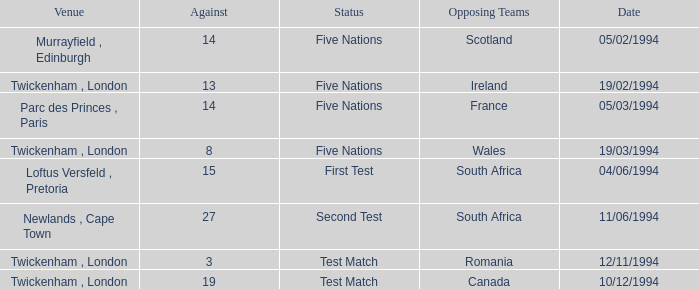How many against have a status of first test? 1.0. 